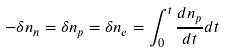<formula> <loc_0><loc_0><loc_500><loc_500>- \delta n _ { n } = \delta n _ { p } = \delta n _ { e } = \int _ { 0 } ^ { t } \frac { d n _ { p } } { d t } d t</formula> 